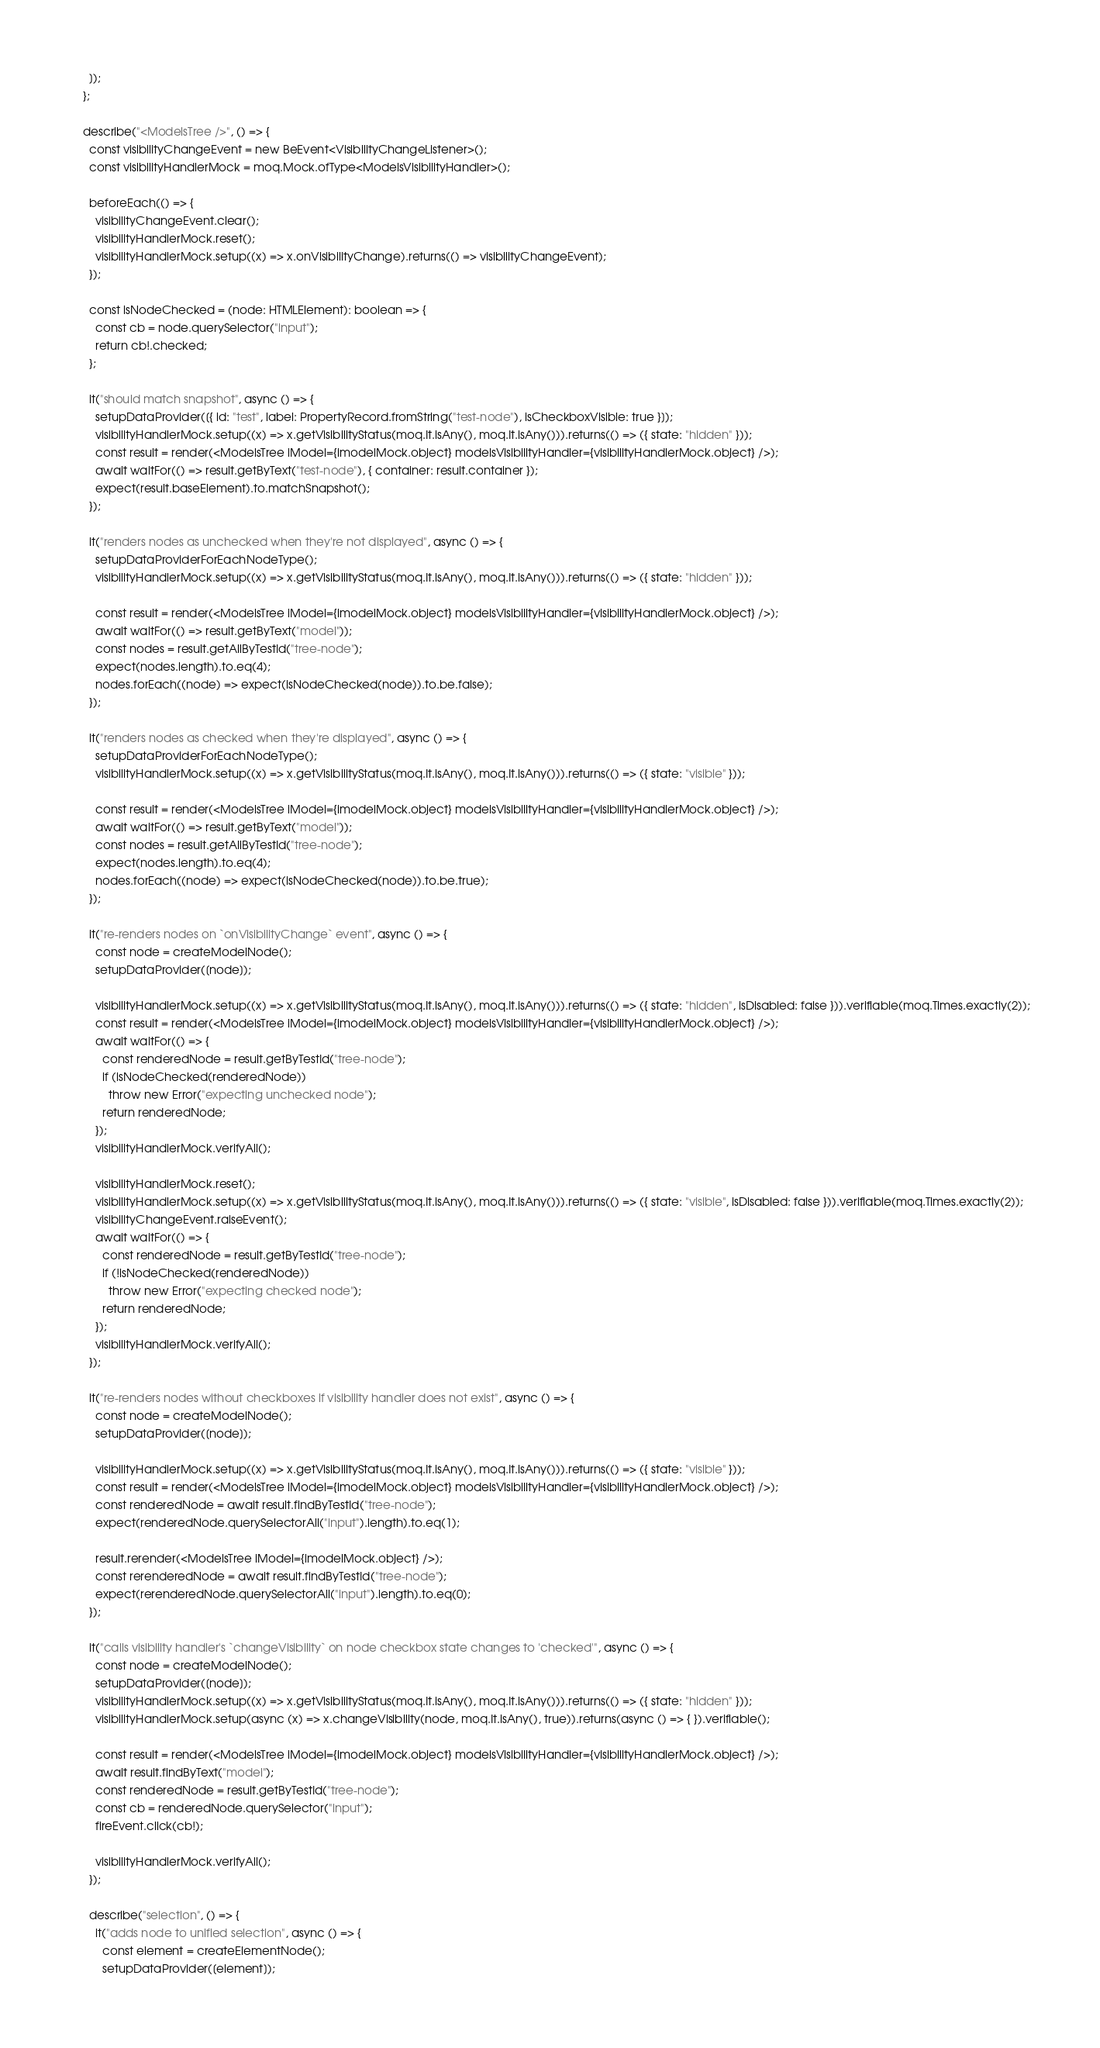Convert code to text. <code><loc_0><loc_0><loc_500><loc_500><_TypeScript_>      ]);
    };

    describe("<ModelsTree />", () => {
      const visibilityChangeEvent = new BeEvent<VisibilityChangeListener>();
      const visibilityHandlerMock = moq.Mock.ofType<ModelsVisibilityHandler>();

      beforeEach(() => {
        visibilityChangeEvent.clear();
        visibilityHandlerMock.reset();
        visibilityHandlerMock.setup((x) => x.onVisibilityChange).returns(() => visibilityChangeEvent);
      });

      const isNodeChecked = (node: HTMLElement): boolean => {
        const cb = node.querySelector("input");
        return cb!.checked;
      };

      it("should match snapshot", async () => {
        setupDataProvider([{ id: "test", label: PropertyRecord.fromString("test-node"), isCheckboxVisible: true }]);
        visibilityHandlerMock.setup((x) => x.getVisibilityStatus(moq.It.isAny(), moq.It.isAny())).returns(() => ({ state: "hidden" }));
        const result = render(<ModelsTree iModel={imodelMock.object} modelsVisibilityHandler={visibilityHandlerMock.object} />);
        await waitFor(() => result.getByText("test-node"), { container: result.container });
        expect(result.baseElement).to.matchSnapshot();
      });

      it("renders nodes as unchecked when they're not displayed", async () => {
        setupDataProviderForEachNodeType();
        visibilityHandlerMock.setup((x) => x.getVisibilityStatus(moq.It.isAny(), moq.It.isAny())).returns(() => ({ state: "hidden" }));

        const result = render(<ModelsTree iModel={imodelMock.object} modelsVisibilityHandler={visibilityHandlerMock.object} />);
        await waitFor(() => result.getByText("model"));
        const nodes = result.getAllByTestId("tree-node");
        expect(nodes.length).to.eq(4);
        nodes.forEach((node) => expect(isNodeChecked(node)).to.be.false);
      });

      it("renders nodes as checked when they're displayed", async () => {
        setupDataProviderForEachNodeType();
        visibilityHandlerMock.setup((x) => x.getVisibilityStatus(moq.It.isAny(), moq.It.isAny())).returns(() => ({ state: "visible" }));

        const result = render(<ModelsTree iModel={imodelMock.object} modelsVisibilityHandler={visibilityHandlerMock.object} />);
        await waitFor(() => result.getByText("model"));
        const nodes = result.getAllByTestId("tree-node");
        expect(nodes.length).to.eq(4);
        nodes.forEach((node) => expect(isNodeChecked(node)).to.be.true);
      });

      it("re-renders nodes on `onVisibilityChange` event", async () => {
        const node = createModelNode();
        setupDataProvider([node]);

        visibilityHandlerMock.setup((x) => x.getVisibilityStatus(moq.It.isAny(), moq.It.isAny())).returns(() => ({ state: "hidden", isDisabled: false })).verifiable(moq.Times.exactly(2));
        const result = render(<ModelsTree iModel={imodelMock.object} modelsVisibilityHandler={visibilityHandlerMock.object} />);
        await waitFor(() => {
          const renderedNode = result.getByTestId("tree-node");
          if (isNodeChecked(renderedNode))
            throw new Error("expecting unchecked node");
          return renderedNode;
        });
        visibilityHandlerMock.verifyAll();

        visibilityHandlerMock.reset();
        visibilityHandlerMock.setup((x) => x.getVisibilityStatus(moq.It.isAny(), moq.It.isAny())).returns(() => ({ state: "visible", isDisabled: false })).verifiable(moq.Times.exactly(2));
        visibilityChangeEvent.raiseEvent();
        await waitFor(() => {
          const renderedNode = result.getByTestId("tree-node");
          if (!isNodeChecked(renderedNode))
            throw new Error("expecting checked node");
          return renderedNode;
        });
        visibilityHandlerMock.verifyAll();
      });

      it("re-renders nodes without checkboxes if visibility handler does not exist", async () => {
        const node = createModelNode();
        setupDataProvider([node]);

        visibilityHandlerMock.setup((x) => x.getVisibilityStatus(moq.It.isAny(), moq.It.isAny())).returns(() => ({ state: "visible" }));
        const result = render(<ModelsTree iModel={imodelMock.object} modelsVisibilityHandler={visibilityHandlerMock.object} />);
        const renderedNode = await result.findByTestId("tree-node");
        expect(renderedNode.querySelectorAll("input").length).to.eq(1);

        result.rerender(<ModelsTree iModel={imodelMock.object} />);
        const rerenderedNode = await result.findByTestId("tree-node");
        expect(rerenderedNode.querySelectorAll("input").length).to.eq(0);
      });

      it("calls visibility handler's `changeVisibility` on node checkbox state changes to 'checked'", async () => {
        const node = createModelNode();
        setupDataProvider([node]);
        visibilityHandlerMock.setup((x) => x.getVisibilityStatus(moq.It.isAny(), moq.It.isAny())).returns(() => ({ state: "hidden" }));
        visibilityHandlerMock.setup(async (x) => x.changeVisibility(node, moq.It.isAny(), true)).returns(async () => { }).verifiable();

        const result = render(<ModelsTree iModel={imodelMock.object} modelsVisibilityHandler={visibilityHandlerMock.object} />);
        await result.findByText("model");
        const renderedNode = result.getByTestId("tree-node");
        const cb = renderedNode.querySelector("input");
        fireEvent.click(cb!);

        visibilityHandlerMock.verifyAll();
      });

      describe("selection", () => {
        it("adds node to unified selection", async () => {
          const element = createElementNode();
          setupDataProvider([element]);</code> 